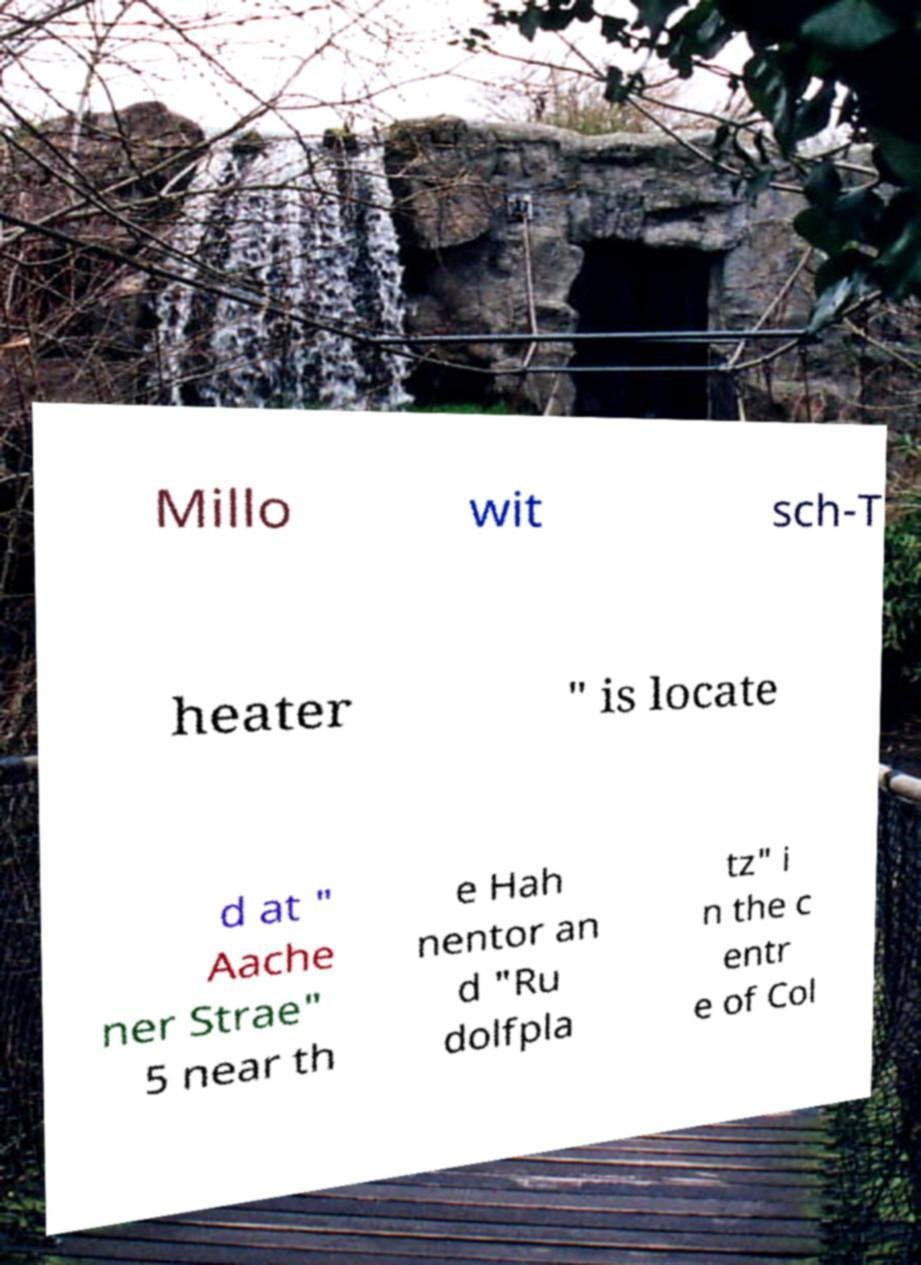There's text embedded in this image that I need extracted. Can you transcribe it verbatim? Millo wit sch-T heater " is locate d at " Aache ner Strae" 5 near th e Hah nentor an d "Ru dolfpla tz" i n the c entr e of Col 